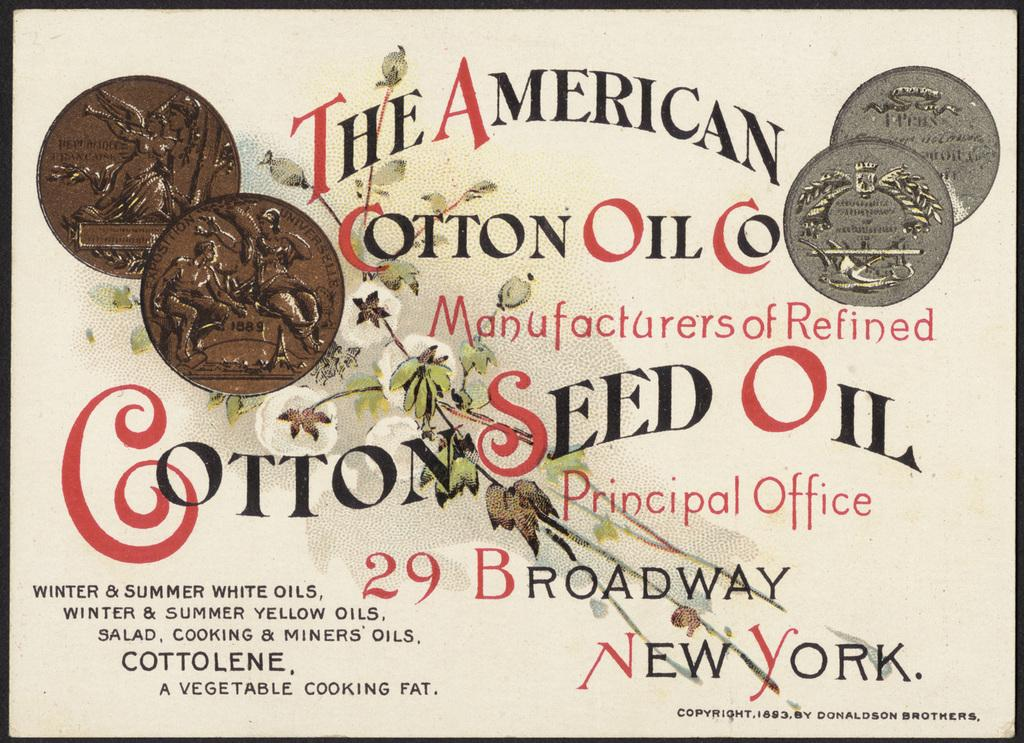<image>
Write a terse but informative summary of the picture. Cotton Seed Oil from The American Cotton Oil Co is displayed on this old time advert. 